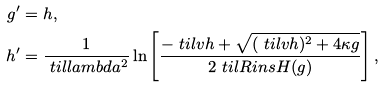Convert formula to latex. <formula><loc_0><loc_0><loc_500><loc_500>g ^ { \prime } & = h , \\ h ^ { \prime } & = \frac { 1 } { \ t i l l a m b d a ^ { 2 } } \ln \left [ \frac { - \ t i l v h + \sqrt { ( \ t i l v h ) ^ { 2 } + 4 \kappa g } } { 2 \ t i l R i n s H ( g ) } \right ] ,</formula> 